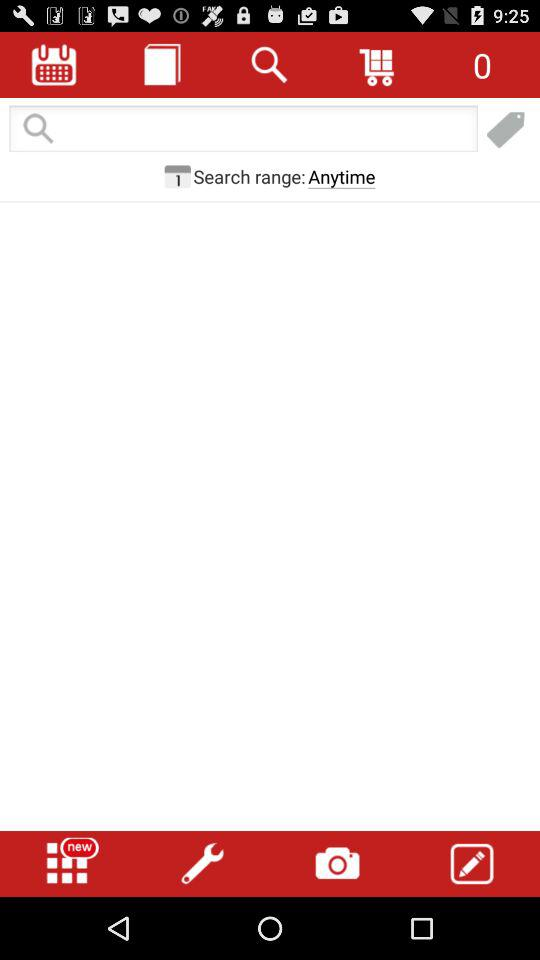Which images are saved?
When the provided information is insufficient, respond with <no answer>. <no answer> 